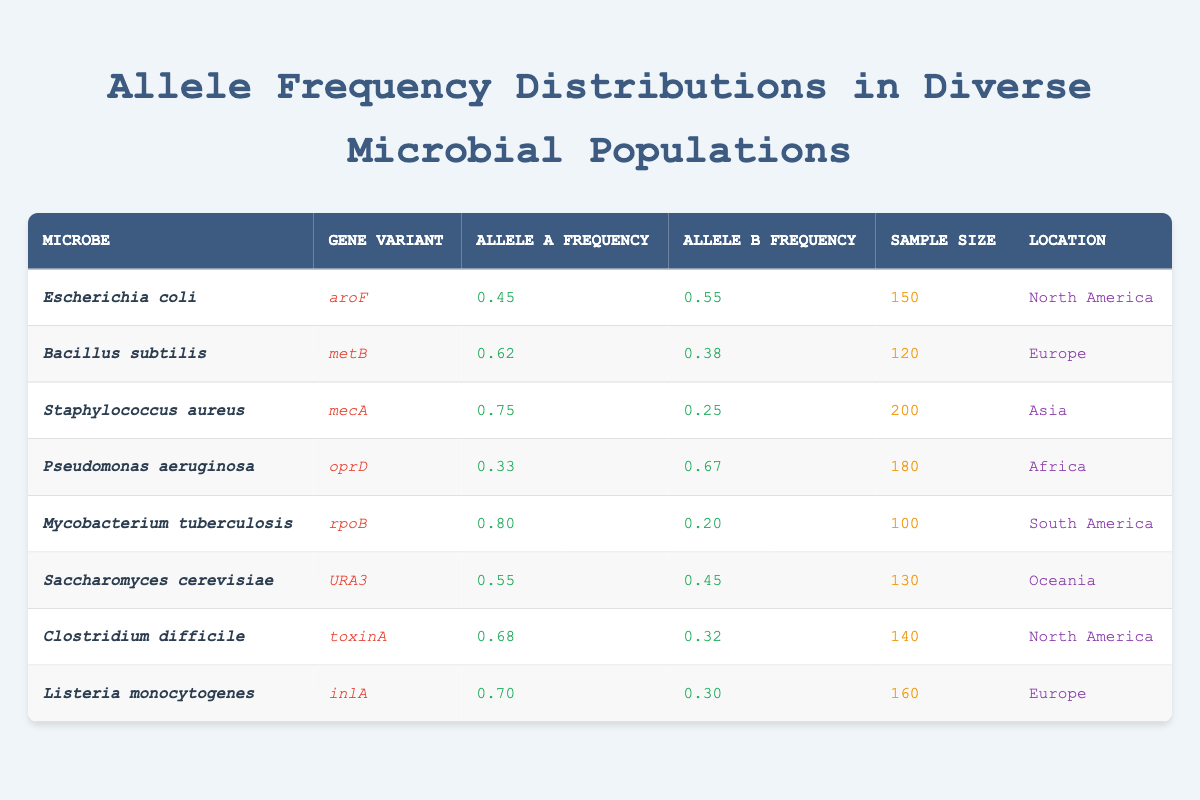What is the allele A frequency of *Staphylococcus aureus* for the gene variant *mecA*? The table shows that for *Staphylococcus aureus* and the gene variant *mecA*, the allele A frequency is listed under the corresponding columns. It is 0.75.
Answer: 0.75 Which location has the highest frequency for allele A? By reviewing the allele A frequencies of all microorganisms, *Mycobacterium tuberculosis* has the highest allele A frequency of 0.80, which is located in South America.
Answer: South America Calculate the average allele B frequency for all microbes listed in the table. The allele B frequencies are 0.55, 0.38, 0.25, 0.67, 0.20, 0.45, 0.32, and 0.30. Summing these gives a total of 2.12 for 8 samples. The average is 2.12/8 = 0.265.
Answer: 0.265 Is the allele A frequency of *Pseudomonas aeruginosa* greater than that of *Bacillus subtilis*? The allele A frequency for *Pseudomonas aeruginosa* is 0.33 while for *Bacillus subtilis* it is 0.62. Since 0.33 is less than 0.62, the statement is false.
Answer: No Which gene variant has the lowest frequency across all samples for allele A? Comparing all allele A frequencies: they are 0.45, 0.62, 0.75, 0.33, 0.80, 0.55, 0.68, and 0.70. The minimum frequency is 0.33, which is associated with the gene variant *oprD* of *Pseudomonas aeruginosa*.
Answer: oprD Find the location with the highest sample size and identify which microbe is associated with it. The sample sizes listed are 150, 120, 200, 180, 100, 130, 140, and 160. The highest sample size is 200 for *Staphylococcus aureus* in Asia.
Answer: Asia (Staphylococcus aureus) What is the difference between allele A frequencies of *Mycobacterium tuberculosis* and *Clostridium difficile*? The allele A frequency for *Mycobacterium tuberculosis* is 0.80 and for *Clostridium difficile* it is 0.68. The difference is calculated as 0.80 - 0.68 = 0.12.
Answer: 0.12 Does *Saccharomyces cerevisiae* have a higher allele A frequency than *Listeria monocytogenes*? The allele A frequency for *Saccharomyces cerevisiae* is 0.55, while for *Listeria monocytogenes* it is 0.70. Since 0.55 is less than 0.70, the statement is false.
Answer: No Identify the microbe with the lowest allele B frequency and provide its value. The allele B frequencies are 0.55, 0.38, 0.25, 0.67, 0.20, 0.45, 0.32, and 0.30. The lowest value is 0.20, which corresponds to *Mycobacterium tuberculosis*.
Answer: 0.20 